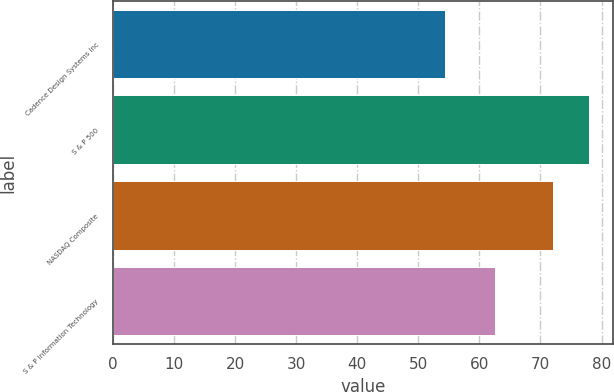Convert chart to OTSL. <chart><loc_0><loc_0><loc_500><loc_500><bar_chart><fcel>Cadence Design Systems Inc<fcel>S & P 500<fcel>NASDAQ Composite<fcel>S & P Information Technology<nl><fcel>54.38<fcel>77.9<fcel>71.97<fcel>62.59<nl></chart> 